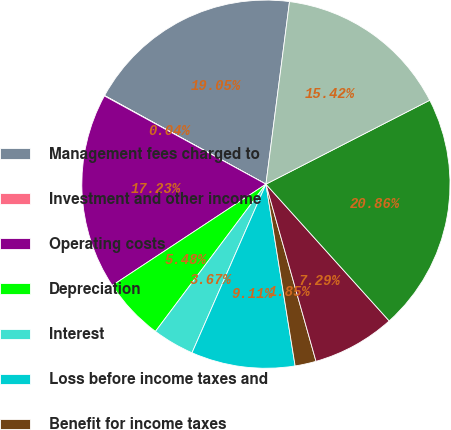Convert chart to OTSL. <chart><loc_0><loc_0><loc_500><loc_500><pie_chart><fcel>Management fees charged to<fcel>Investment and other income<fcel>Operating costs<fcel>Depreciation<fcel>Interest<fcel>Loss before income taxes and<fcel>Benefit for income taxes<fcel>Loss before equity in net<fcel>Equity in net earnings of<fcel>Net income<nl><fcel>19.05%<fcel>0.04%<fcel>17.23%<fcel>5.48%<fcel>3.67%<fcel>9.11%<fcel>1.85%<fcel>7.29%<fcel>20.86%<fcel>15.42%<nl></chart> 